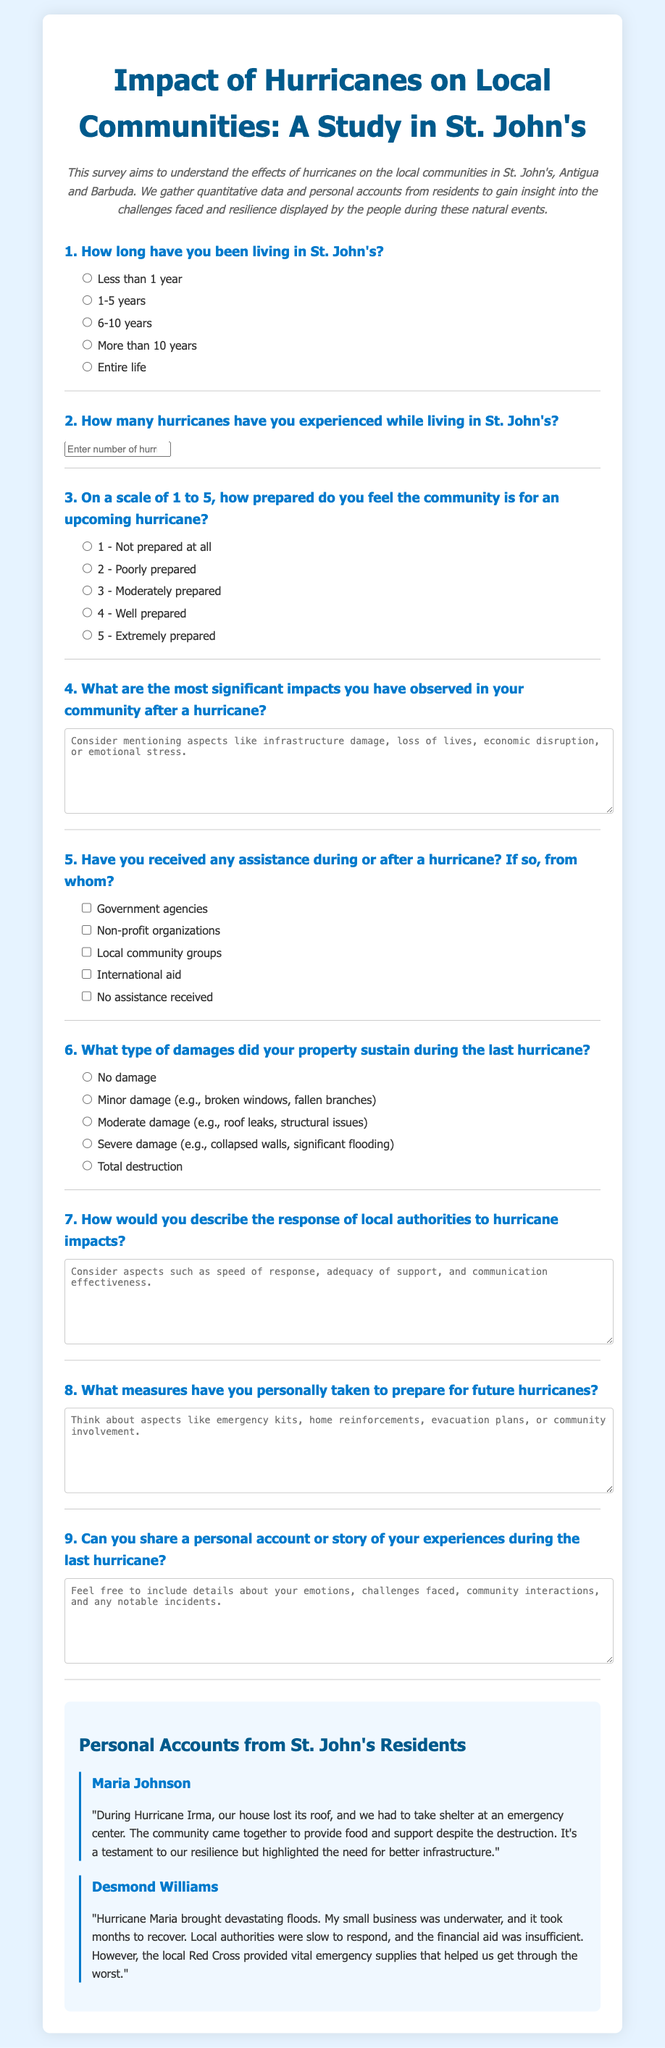What is the title of the survey? The title of the survey is provided at the top of the document, indicating its focus on the impact of hurricanes on local communities in St. John's.
Answer: Impact of Hurricanes on Local Communities: A Study in St. John's How many personal accounts are shared in the document? The document contains two personal accounts from residents in St. John's, highlighting their experiences during hurricanes.
Answer: 2 What scale is used to measure community preparedness? The survey question uses a scale from 1 to 5, with 1 being "Not prepared at all" and 5 being "Extremely prepared."
Answer: 1 to 5 What type of assistance is most likely received according to the options? Several options are provided for types of assistance, including government agencies, non-profit organizations, and local community groups. The most common types mentioned are likely among these.
Answer: Government agencies, Non-profit organizations, Local community groups What kind of damages might a property sustain during a hurricane? The survey includes options for property damage categories such as no damage, minor damage, moderate damage, severe damage, and total destruction.
Answer: No damage, Minor damage, Moderate damage, Severe damage, Total destruction What does Maria Johnson mention about community support? Maria Johnson emphasizes the importance of community coming together to provide food and support despite the challenges faced during Hurricane Irma.
Answer: Community came together to provide food and support What is an example of a significant impact mentioned by Desmond Williams? Desmond Williams states that his small business was underwater due to flooding caused by Hurricane Maria, showing the economic impacts of hurricanes.
Answer: My small business was underwater On what aspect does the document suggest local authorities could improve? Both personal accounts suggest that the speed of response and adequacy of support from local authorities need improvement after hurricane impacts.
Answer: Speed of response, adequacy of support 